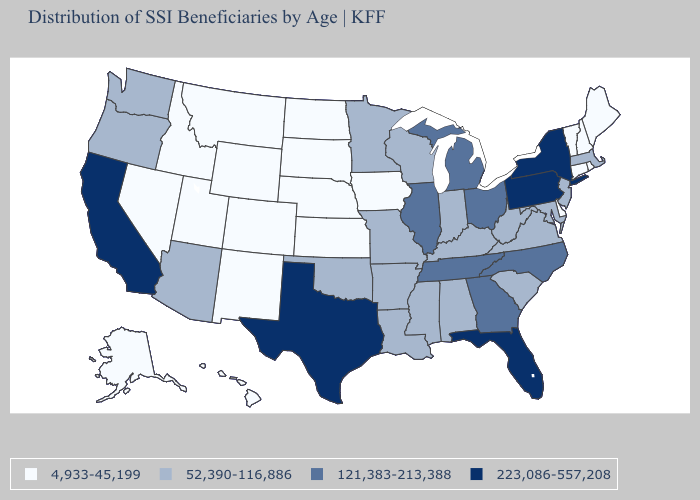Name the states that have a value in the range 223,086-557,208?
Give a very brief answer. California, Florida, New York, Pennsylvania, Texas. Which states hav the highest value in the South?
Quick response, please. Florida, Texas. What is the value of New York?
Keep it brief. 223,086-557,208. What is the value of Alaska?
Write a very short answer. 4,933-45,199. Which states have the lowest value in the USA?
Quick response, please. Alaska, Colorado, Connecticut, Delaware, Hawaii, Idaho, Iowa, Kansas, Maine, Montana, Nebraska, Nevada, New Hampshire, New Mexico, North Dakota, Rhode Island, South Dakota, Utah, Vermont, Wyoming. Does Illinois have a lower value than Pennsylvania?
Keep it brief. Yes. Is the legend a continuous bar?
Keep it brief. No. What is the value of Wisconsin?
Short answer required. 52,390-116,886. What is the highest value in the USA?
Be succinct. 223,086-557,208. Which states have the lowest value in the Northeast?
Keep it brief. Connecticut, Maine, New Hampshire, Rhode Island, Vermont. Does Nebraska have the same value as Delaware?
Keep it brief. Yes. Among the states that border Virginia , does Kentucky have the highest value?
Short answer required. No. What is the value of Missouri?
Quick response, please. 52,390-116,886. Is the legend a continuous bar?
Be succinct. No. Which states have the lowest value in the West?
Short answer required. Alaska, Colorado, Hawaii, Idaho, Montana, Nevada, New Mexico, Utah, Wyoming. 